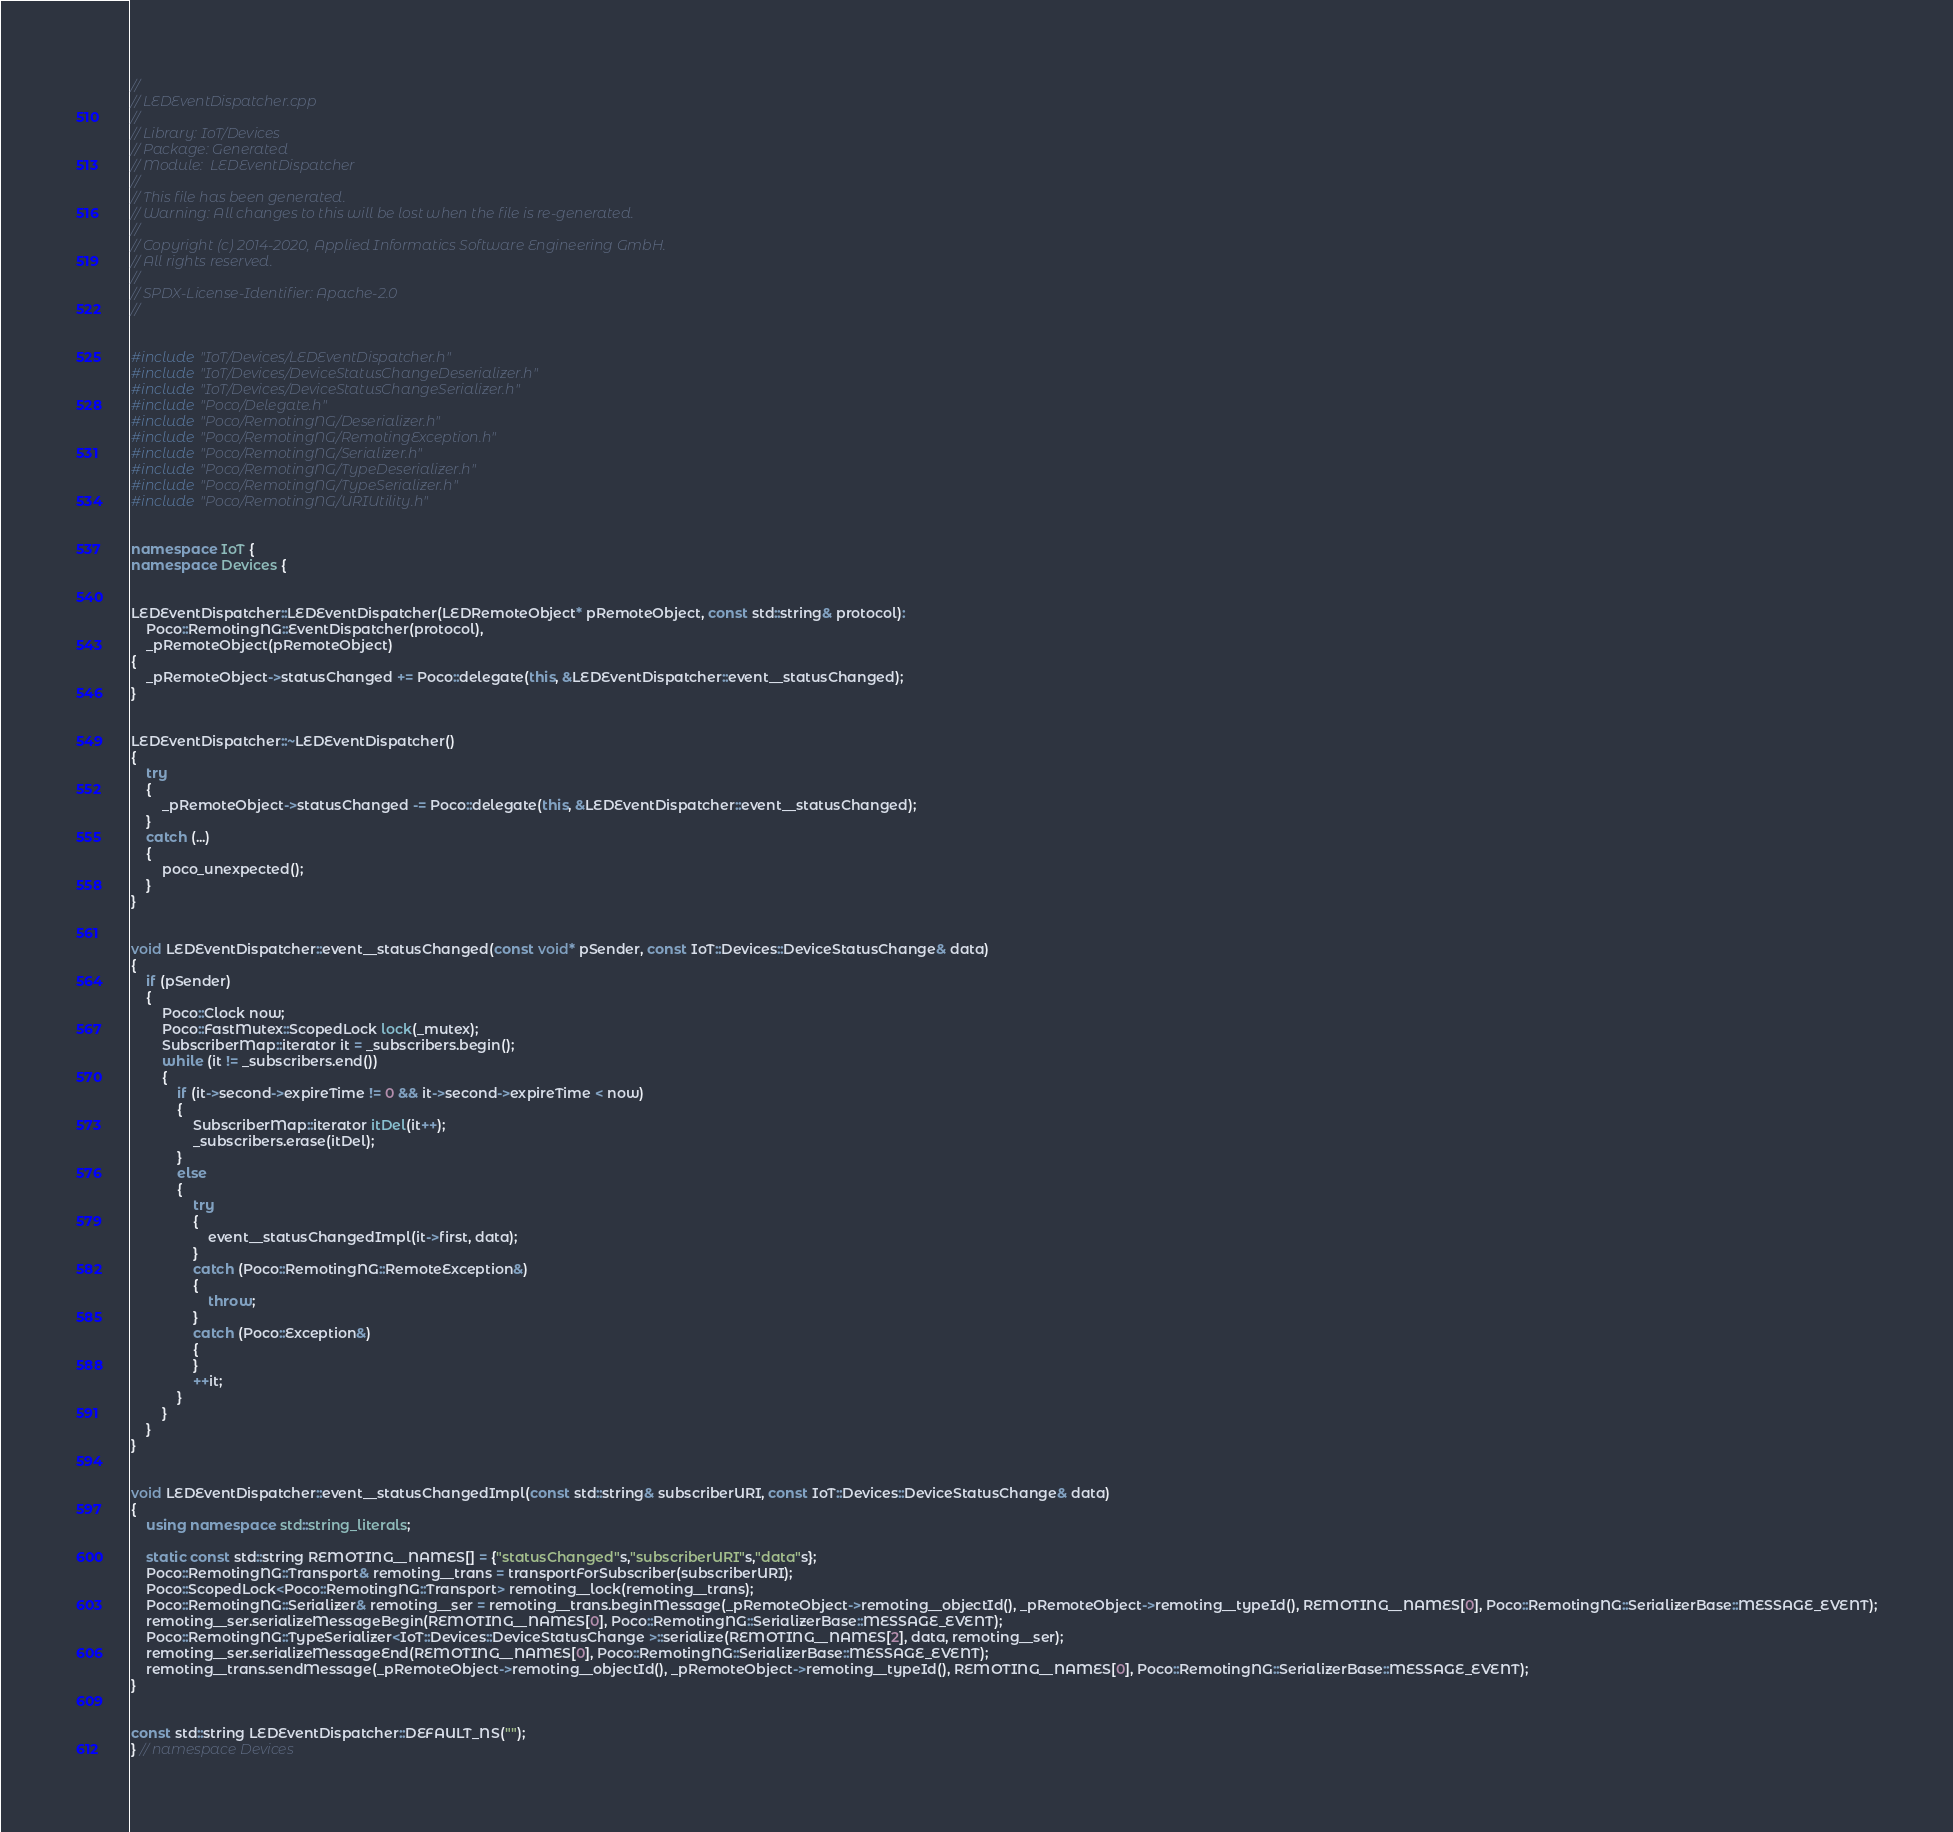Convert code to text. <code><loc_0><loc_0><loc_500><loc_500><_C++_>//
// LEDEventDispatcher.cpp
//
// Library: IoT/Devices
// Package: Generated
// Module:  LEDEventDispatcher
//
// This file has been generated.
// Warning: All changes to this will be lost when the file is re-generated.
//
// Copyright (c) 2014-2020, Applied Informatics Software Engineering GmbH.
// All rights reserved.
// 
// SPDX-License-Identifier: Apache-2.0
//


#include "IoT/Devices/LEDEventDispatcher.h"
#include "IoT/Devices/DeviceStatusChangeDeserializer.h"
#include "IoT/Devices/DeviceStatusChangeSerializer.h"
#include "Poco/Delegate.h"
#include "Poco/RemotingNG/Deserializer.h"
#include "Poco/RemotingNG/RemotingException.h"
#include "Poco/RemotingNG/Serializer.h"
#include "Poco/RemotingNG/TypeDeserializer.h"
#include "Poco/RemotingNG/TypeSerializer.h"
#include "Poco/RemotingNG/URIUtility.h"


namespace IoT {
namespace Devices {


LEDEventDispatcher::LEDEventDispatcher(LEDRemoteObject* pRemoteObject, const std::string& protocol):
	Poco::RemotingNG::EventDispatcher(protocol),
	_pRemoteObject(pRemoteObject)
{
	_pRemoteObject->statusChanged += Poco::delegate(this, &LEDEventDispatcher::event__statusChanged);
}


LEDEventDispatcher::~LEDEventDispatcher()
{
	try
	{
		_pRemoteObject->statusChanged -= Poco::delegate(this, &LEDEventDispatcher::event__statusChanged);
	}
	catch (...)
	{
		poco_unexpected();
	}
}


void LEDEventDispatcher::event__statusChanged(const void* pSender, const IoT::Devices::DeviceStatusChange& data)
{
	if (pSender)
	{
		Poco::Clock now;
		Poco::FastMutex::ScopedLock lock(_mutex);
		SubscriberMap::iterator it = _subscribers.begin();
		while (it != _subscribers.end())
		{
			if (it->second->expireTime != 0 && it->second->expireTime < now)
			{
				SubscriberMap::iterator itDel(it++);
				_subscribers.erase(itDel);
			}
			else
			{
				try
				{
					event__statusChangedImpl(it->first, data);
				}
				catch (Poco::RemotingNG::RemoteException&)
				{
					throw;
				}
				catch (Poco::Exception&)
				{
				}
				++it;
			}
		}
	}
}


void LEDEventDispatcher::event__statusChangedImpl(const std::string& subscriberURI, const IoT::Devices::DeviceStatusChange& data)
{
	using namespace std::string_literals;
	
	static const std::string REMOTING__NAMES[] = {"statusChanged"s,"subscriberURI"s,"data"s};
	Poco::RemotingNG::Transport& remoting__trans = transportForSubscriber(subscriberURI);
	Poco::ScopedLock<Poco::RemotingNG::Transport> remoting__lock(remoting__trans);
	Poco::RemotingNG::Serializer& remoting__ser = remoting__trans.beginMessage(_pRemoteObject->remoting__objectId(), _pRemoteObject->remoting__typeId(), REMOTING__NAMES[0], Poco::RemotingNG::SerializerBase::MESSAGE_EVENT);
	remoting__ser.serializeMessageBegin(REMOTING__NAMES[0], Poco::RemotingNG::SerializerBase::MESSAGE_EVENT);
	Poco::RemotingNG::TypeSerializer<IoT::Devices::DeviceStatusChange >::serialize(REMOTING__NAMES[2], data, remoting__ser);
	remoting__ser.serializeMessageEnd(REMOTING__NAMES[0], Poco::RemotingNG::SerializerBase::MESSAGE_EVENT);
	remoting__trans.sendMessage(_pRemoteObject->remoting__objectId(), _pRemoteObject->remoting__typeId(), REMOTING__NAMES[0], Poco::RemotingNG::SerializerBase::MESSAGE_EVENT);
}


const std::string LEDEventDispatcher::DEFAULT_NS("");
} // namespace Devices</code> 